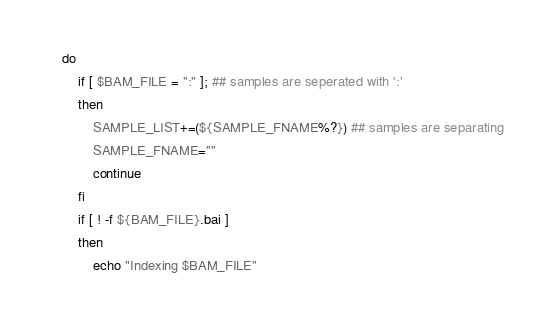Convert code to text. <code><loc_0><loc_0><loc_500><loc_500><_Bash_>    do
        if [ $BAM_FILE = ":" ]; ## samples are seperated with ':'
        then
            SAMPLE_LIST+=(${SAMPLE_FNAME%?}) ## samples are separating 
            SAMPLE_FNAME=""
            continue
        fi
        if [ ! -f ${BAM_FILE}.bai ]
        then
            echo "Indexing $BAM_FILE"</code> 